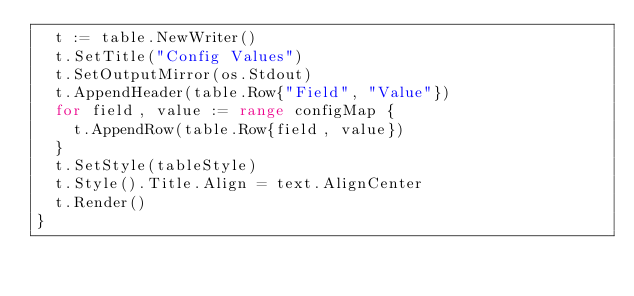Convert code to text. <code><loc_0><loc_0><loc_500><loc_500><_Go_>	t := table.NewWriter()
	t.SetTitle("Config Values")
	t.SetOutputMirror(os.Stdout)
	t.AppendHeader(table.Row{"Field", "Value"})
	for field, value := range configMap {
		t.AppendRow(table.Row{field, value})
	}
	t.SetStyle(tableStyle)
	t.Style().Title.Align = text.AlignCenter
	t.Render()
}
</code> 